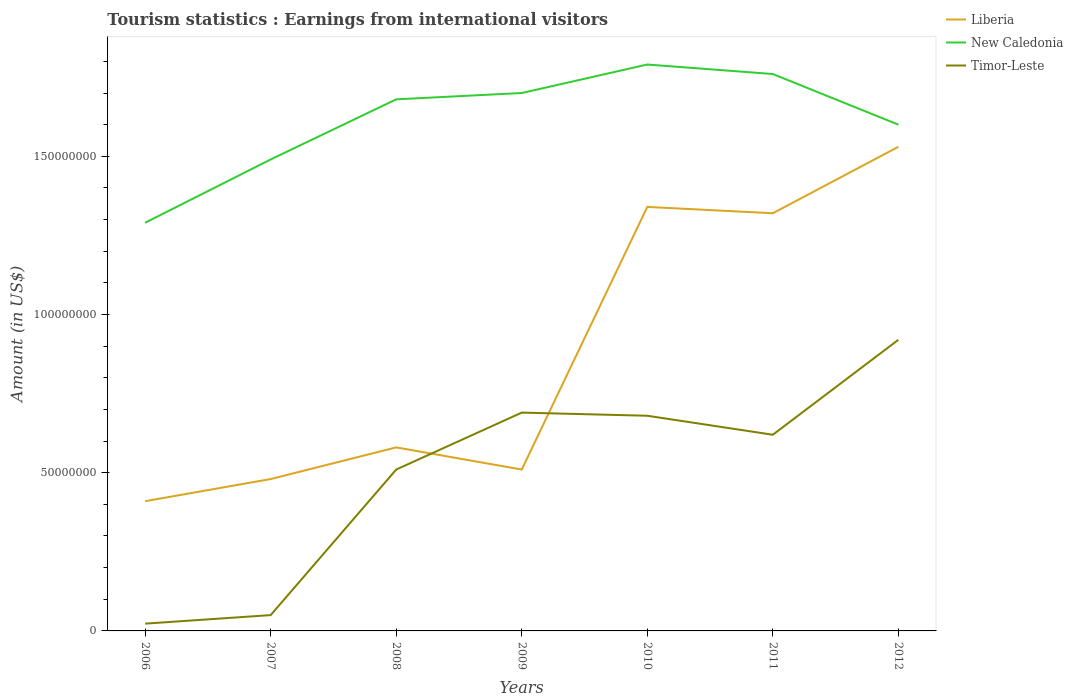How many different coloured lines are there?
Keep it short and to the point. 3. Does the line corresponding to Timor-Leste intersect with the line corresponding to Liberia?
Keep it short and to the point. Yes. Is the number of lines equal to the number of legend labels?
Offer a terse response. Yes. Across all years, what is the maximum earnings from international visitors in Liberia?
Offer a terse response. 4.10e+07. What is the total earnings from international visitors in Timor-Leste in the graph?
Your answer should be very brief. -1.80e+07. What is the difference between the highest and the second highest earnings from international visitors in Timor-Leste?
Make the answer very short. 8.97e+07. Is the earnings from international visitors in Liberia strictly greater than the earnings from international visitors in Timor-Leste over the years?
Provide a succinct answer. No. How many lines are there?
Provide a short and direct response. 3. How many years are there in the graph?
Provide a succinct answer. 7. Does the graph contain any zero values?
Provide a succinct answer. No. Does the graph contain grids?
Keep it short and to the point. No. Where does the legend appear in the graph?
Your response must be concise. Top right. How are the legend labels stacked?
Offer a very short reply. Vertical. What is the title of the graph?
Your answer should be very brief. Tourism statistics : Earnings from international visitors. What is the Amount (in US$) of Liberia in 2006?
Make the answer very short. 4.10e+07. What is the Amount (in US$) in New Caledonia in 2006?
Give a very brief answer. 1.29e+08. What is the Amount (in US$) in Timor-Leste in 2006?
Provide a succinct answer. 2.30e+06. What is the Amount (in US$) of Liberia in 2007?
Your answer should be compact. 4.80e+07. What is the Amount (in US$) in New Caledonia in 2007?
Provide a succinct answer. 1.49e+08. What is the Amount (in US$) in Timor-Leste in 2007?
Offer a terse response. 5.00e+06. What is the Amount (in US$) in Liberia in 2008?
Keep it short and to the point. 5.80e+07. What is the Amount (in US$) in New Caledonia in 2008?
Provide a succinct answer. 1.68e+08. What is the Amount (in US$) of Timor-Leste in 2008?
Keep it short and to the point. 5.10e+07. What is the Amount (in US$) of Liberia in 2009?
Give a very brief answer. 5.10e+07. What is the Amount (in US$) in New Caledonia in 2009?
Provide a short and direct response. 1.70e+08. What is the Amount (in US$) of Timor-Leste in 2009?
Provide a succinct answer. 6.90e+07. What is the Amount (in US$) in Liberia in 2010?
Provide a short and direct response. 1.34e+08. What is the Amount (in US$) in New Caledonia in 2010?
Provide a succinct answer. 1.79e+08. What is the Amount (in US$) of Timor-Leste in 2010?
Provide a succinct answer. 6.80e+07. What is the Amount (in US$) in Liberia in 2011?
Your answer should be very brief. 1.32e+08. What is the Amount (in US$) of New Caledonia in 2011?
Keep it short and to the point. 1.76e+08. What is the Amount (in US$) in Timor-Leste in 2011?
Keep it short and to the point. 6.20e+07. What is the Amount (in US$) of Liberia in 2012?
Ensure brevity in your answer.  1.53e+08. What is the Amount (in US$) in New Caledonia in 2012?
Your answer should be compact. 1.60e+08. What is the Amount (in US$) of Timor-Leste in 2012?
Your answer should be very brief. 9.20e+07. Across all years, what is the maximum Amount (in US$) of Liberia?
Provide a short and direct response. 1.53e+08. Across all years, what is the maximum Amount (in US$) in New Caledonia?
Provide a short and direct response. 1.79e+08. Across all years, what is the maximum Amount (in US$) of Timor-Leste?
Your response must be concise. 9.20e+07. Across all years, what is the minimum Amount (in US$) in Liberia?
Your answer should be compact. 4.10e+07. Across all years, what is the minimum Amount (in US$) in New Caledonia?
Make the answer very short. 1.29e+08. Across all years, what is the minimum Amount (in US$) in Timor-Leste?
Give a very brief answer. 2.30e+06. What is the total Amount (in US$) in Liberia in the graph?
Provide a succinct answer. 6.17e+08. What is the total Amount (in US$) in New Caledonia in the graph?
Your answer should be very brief. 1.13e+09. What is the total Amount (in US$) of Timor-Leste in the graph?
Give a very brief answer. 3.49e+08. What is the difference between the Amount (in US$) in Liberia in 2006 and that in 2007?
Keep it short and to the point. -7.00e+06. What is the difference between the Amount (in US$) of New Caledonia in 2006 and that in 2007?
Your answer should be compact. -2.00e+07. What is the difference between the Amount (in US$) of Timor-Leste in 2006 and that in 2007?
Offer a terse response. -2.70e+06. What is the difference between the Amount (in US$) in Liberia in 2006 and that in 2008?
Your answer should be very brief. -1.70e+07. What is the difference between the Amount (in US$) of New Caledonia in 2006 and that in 2008?
Offer a very short reply. -3.90e+07. What is the difference between the Amount (in US$) in Timor-Leste in 2006 and that in 2008?
Your answer should be very brief. -4.87e+07. What is the difference between the Amount (in US$) in Liberia in 2006 and that in 2009?
Provide a succinct answer. -1.00e+07. What is the difference between the Amount (in US$) of New Caledonia in 2006 and that in 2009?
Make the answer very short. -4.10e+07. What is the difference between the Amount (in US$) of Timor-Leste in 2006 and that in 2009?
Give a very brief answer. -6.67e+07. What is the difference between the Amount (in US$) in Liberia in 2006 and that in 2010?
Your answer should be very brief. -9.30e+07. What is the difference between the Amount (in US$) of New Caledonia in 2006 and that in 2010?
Offer a terse response. -5.00e+07. What is the difference between the Amount (in US$) in Timor-Leste in 2006 and that in 2010?
Your response must be concise. -6.57e+07. What is the difference between the Amount (in US$) in Liberia in 2006 and that in 2011?
Keep it short and to the point. -9.10e+07. What is the difference between the Amount (in US$) in New Caledonia in 2006 and that in 2011?
Offer a very short reply. -4.70e+07. What is the difference between the Amount (in US$) in Timor-Leste in 2006 and that in 2011?
Offer a terse response. -5.97e+07. What is the difference between the Amount (in US$) in Liberia in 2006 and that in 2012?
Your answer should be compact. -1.12e+08. What is the difference between the Amount (in US$) of New Caledonia in 2006 and that in 2012?
Your answer should be very brief. -3.10e+07. What is the difference between the Amount (in US$) in Timor-Leste in 2006 and that in 2012?
Offer a very short reply. -8.97e+07. What is the difference between the Amount (in US$) of Liberia in 2007 and that in 2008?
Your answer should be compact. -1.00e+07. What is the difference between the Amount (in US$) in New Caledonia in 2007 and that in 2008?
Keep it short and to the point. -1.90e+07. What is the difference between the Amount (in US$) of Timor-Leste in 2007 and that in 2008?
Offer a terse response. -4.60e+07. What is the difference between the Amount (in US$) in Liberia in 2007 and that in 2009?
Make the answer very short. -3.00e+06. What is the difference between the Amount (in US$) in New Caledonia in 2007 and that in 2009?
Make the answer very short. -2.10e+07. What is the difference between the Amount (in US$) of Timor-Leste in 2007 and that in 2009?
Give a very brief answer. -6.40e+07. What is the difference between the Amount (in US$) in Liberia in 2007 and that in 2010?
Your response must be concise. -8.60e+07. What is the difference between the Amount (in US$) of New Caledonia in 2007 and that in 2010?
Give a very brief answer. -3.00e+07. What is the difference between the Amount (in US$) in Timor-Leste in 2007 and that in 2010?
Provide a succinct answer. -6.30e+07. What is the difference between the Amount (in US$) of Liberia in 2007 and that in 2011?
Keep it short and to the point. -8.40e+07. What is the difference between the Amount (in US$) in New Caledonia in 2007 and that in 2011?
Keep it short and to the point. -2.70e+07. What is the difference between the Amount (in US$) of Timor-Leste in 2007 and that in 2011?
Make the answer very short. -5.70e+07. What is the difference between the Amount (in US$) in Liberia in 2007 and that in 2012?
Ensure brevity in your answer.  -1.05e+08. What is the difference between the Amount (in US$) of New Caledonia in 2007 and that in 2012?
Give a very brief answer. -1.10e+07. What is the difference between the Amount (in US$) of Timor-Leste in 2007 and that in 2012?
Provide a short and direct response. -8.70e+07. What is the difference between the Amount (in US$) in Timor-Leste in 2008 and that in 2009?
Offer a terse response. -1.80e+07. What is the difference between the Amount (in US$) in Liberia in 2008 and that in 2010?
Offer a very short reply. -7.60e+07. What is the difference between the Amount (in US$) in New Caledonia in 2008 and that in 2010?
Your answer should be compact. -1.10e+07. What is the difference between the Amount (in US$) of Timor-Leste in 2008 and that in 2010?
Keep it short and to the point. -1.70e+07. What is the difference between the Amount (in US$) of Liberia in 2008 and that in 2011?
Provide a short and direct response. -7.40e+07. What is the difference between the Amount (in US$) in New Caledonia in 2008 and that in 2011?
Make the answer very short. -8.00e+06. What is the difference between the Amount (in US$) of Timor-Leste in 2008 and that in 2011?
Your answer should be very brief. -1.10e+07. What is the difference between the Amount (in US$) of Liberia in 2008 and that in 2012?
Keep it short and to the point. -9.50e+07. What is the difference between the Amount (in US$) of Timor-Leste in 2008 and that in 2012?
Your response must be concise. -4.10e+07. What is the difference between the Amount (in US$) in Liberia in 2009 and that in 2010?
Keep it short and to the point. -8.30e+07. What is the difference between the Amount (in US$) of New Caledonia in 2009 and that in 2010?
Your answer should be compact. -9.00e+06. What is the difference between the Amount (in US$) in Timor-Leste in 2009 and that in 2010?
Offer a very short reply. 1.00e+06. What is the difference between the Amount (in US$) of Liberia in 2009 and that in 2011?
Provide a short and direct response. -8.10e+07. What is the difference between the Amount (in US$) in New Caledonia in 2009 and that in 2011?
Provide a succinct answer. -6.00e+06. What is the difference between the Amount (in US$) of Liberia in 2009 and that in 2012?
Give a very brief answer. -1.02e+08. What is the difference between the Amount (in US$) in Timor-Leste in 2009 and that in 2012?
Your answer should be compact. -2.30e+07. What is the difference between the Amount (in US$) in Liberia in 2010 and that in 2011?
Your answer should be very brief. 2.00e+06. What is the difference between the Amount (in US$) of Timor-Leste in 2010 and that in 2011?
Your response must be concise. 6.00e+06. What is the difference between the Amount (in US$) in Liberia in 2010 and that in 2012?
Make the answer very short. -1.90e+07. What is the difference between the Amount (in US$) of New Caledonia in 2010 and that in 2012?
Provide a succinct answer. 1.90e+07. What is the difference between the Amount (in US$) in Timor-Leste in 2010 and that in 2012?
Give a very brief answer. -2.40e+07. What is the difference between the Amount (in US$) in Liberia in 2011 and that in 2012?
Provide a short and direct response. -2.10e+07. What is the difference between the Amount (in US$) of New Caledonia in 2011 and that in 2012?
Your answer should be compact. 1.60e+07. What is the difference between the Amount (in US$) of Timor-Leste in 2011 and that in 2012?
Offer a terse response. -3.00e+07. What is the difference between the Amount (in US$) in Liberia in 2006 and the Amount (in US$) in New Caledonia in 2007?
Offer a terse response. -1.08e+08. What is the difference between the Amount (in US$) of Liberia in 2006 and the Amount (in US$) of Timor-Leste in 2007?
Provide a short and direct response. 3.60e+07. What is the difference between the Amount (in US$) of New Caledonia in 2006 and the Amount (in US$) of Timor-Leste in 2007?
Offer a terse response. 1.24e+08. What is the difference between the Amount (in US$) of Liberia in 2006 and the Amount (in US$) of New Caledonia in 2008?
Provide a succinct answer. -1.27e+08. What is the difference between the Amount (in US$) of Liberia in 2006 and the Amount (in US$) of Timor-Leste in 2008?
Your response must be concise. -1.00e+07. What is the difference between the Amount (in US$) of New Caledonia in 2006 and the Amount (in US$) of Timor-Leste in 2008?
Offer a very short reply. 7.80e+07. What is the difference between the Amount (in US$) of Liberia in 2006 and the Amount (in US$) of New Caledonia in 2009?
Offer a terse response. -1.29e+08. What is the difference between the Amount (in US$) in Liberia in 2006 and the Amount (in US$) in Timor-Leste in 2009?
Offer a very short reply. -2.80e+07. What is the difference between the Amount (in US$) in New Caledonia in 2006 and the Amount (in US$) in Timor-Leste in 2009?
Your answer should be compact. 6.00e+07. What is the difference between the Amount (in US$) of Liberia in 2006 and the Amount (in US$) of New Caledonia in 2010?
Make the answer very short. -1.38e+08. What is the difference between the Amount (in US$) of Liberia in 2006 and the Amount (in US$) of Timor-Leste in 2010?
Provide a succinct answer. -2.70e+07. What is the difference between the Amount (in US$) of New Caledonia in 2006 and the Amount (in US$) of Timor-Leste in 2010?
Your answer should be very brief. 6.10e+07. What is the difference between the Amount (in US$) in Liberia in 2006 and the Amount (in US$) in New Caledonia in 2011?
Keep it short and to the point. -1.35e+08. What is the difference between the Amount (in US$) of Liberia in 2006 and the Amount (in US$) of Timor-Leste in 2011?
Keep it short and to the point. -2.10e+07. What is the difference between the Amount (in US$) in New Caledonia in 2006 and the Amount (in US$) in Timor-Leste in 2011?
Provide a succinct answer. 6.70e+07. What is the difference between the Amount (in US$) in Liberia in 2006 and the Amount (in US$) in New Caledonia in 2012?
Your answer should be very brief. -1.19e+08. What is the difference between the Amount (in US$) of Liberia in 2006 and the Amount (in US$) of Timor-Leste in 2012?
Your answer should be compact. -5.10e+07. What is the difference between the Amount (in US$) in New Caledonia in 2006 and the Amount (in US$) in Timor-Leste in 2012?
Provide a succinct answer. 3.70e+07. What is the difference between the Amount (in US$) of Liberia in 2007 and the Amount (in US$) of New Caledonia in 2008?
Offer a very short reply. -1.20e+08. What is the difference between the Amount (in US$) in New Caledonia in 2007 and the Amount (in US$) in Timor-Leste in 2008?
Keep it short and to the point. 9.80e+07. What is the difference between the Amount (in US$) of Liberia in 2007 and the Amount (in US$) of New Caledonia in 2009?
Make the answer very short. -1.22e+08. What is the difference between the Amount (in US$) in Liberia in 2007 and the Amount (in US$) in Timor-Leste in 2009?
Provide a succinct answer. -2.10e+07. What is the difference between the Amount (in US$) of New Caledonia in 2007 and the Amount (in US$) of Timor-Leste in 2009?
Make the answer very short. 8.00e+07. What is the difference between the Amount (in US$) of Liberia in 2007 and the Amount (in US$) of New Caledonia in 2010?
Your answer should be compact. -1.31e+08. What is the difference between the Amount (in US$) in Liberia in 2007 and the Amount (in US$) in Timor-Leste in 2010?
Provide a short and direct response. -2.00e+07. What is the difference between the Amount (in US$) in New Caledonia in 2007 and the Amount (in US$) in Timor-Leste in 2010?
Keep it short and to the point. 8.10e+07. What is the difference between the Amount (in US$) in Liberia in 2007 and the Amount (in US$) in New Caledonia in 2011?
Your answer should be very brief. -1.28e+08. What is the difference between the Amount (in US$) in Liberia in 2007 and the Amount (in US$) in Timor-Leste in 2011?
Your response must be concise. -1.40e+07. What is the difference between the Amount (in US$) in New Caledonia in 2007 and the Amount (in US$) in Timor-Leste in 2011?
Your answer should be very brief. 8.70e+07. What is the difference between the Amount (in US$) in Liberia in 2007 and the Amount (in US$) in New Caledonia in 2012?
Ensure brevity in your answer.  -1.12e+08. What is the difference between the Amount (in US$) in Liberia in 2007 and the Amount (in US$) in Timor-Leste in 2012?
Your response must be concise. -4.40e+07. What is the difference between the Amount (in US$) of New Caledonia in 2007 and the Amount (in US$) of Timor-Leste in 2012?
Keep it short and to the point. 5.70e+07. What is the difference between the Amount (in US$) in Liberia in 2008 and the Amount (in US$) in New Caledonia in 2009?
Provide a succinct answer. -1.12e+08. What is the difference between the Amount (in US$) of Liberia in 2008 and the Amount (in US$) of Timor-Leste in 2009?
Your answer should be very brief. -1.10e+07. What is the difference between the Amount (in US$) of New Caledonia in 2008 and the Amount (in US$) of Timor-Leste in 2009?
Your answer should be very brief. 9.90e+07. What is the difference between the Amount (in US$) of Liberia in 2008 and the Amount (in US$) of New Caledonia in 2010?
Provide a short and direct response. -1.21e+08. What is the difference between the Amount (in US$) in Liberia in 2008 and the Amount (in US$) in Timor-Leste in 2010?
Give a very brief answer. -1.00e+07. What is the difference between the Amount (in US$) in Liberia in 2008 and the Amount (in US$) in New Caledonia in 2011?
Offer a very short reply. -1.18e+08. What is the difference between the Amount (in US$) in New Caledonia in 2008 and the Amount (in US$) in Timor-Leste in 2011?
Give a very brief answer. 1.06e+08. What is the difference between the Amount (in US$) of Liberia in 2008 and the Amount (in US$) of New Caledonia in 2012?
Your answer should be compact. -1.02e+08. What is the difference between the Amount (in US$) of Liberia in 2008 and the Amount (in US$) of Timor-Leste in 2012?
Ensure brevity in your answer.  -3.40e+07. What is the difference between the Amount (in US$) in New Caledonia in 2008 and the Amount (in US$) in Timor-Leste in 2012?
Provide a short and direct response. 7.60e+07. What is the difference between the Amount (in US$) of Liberia in 2009 and the Amount (in US$) of New Caledonia in 2010?
Make the answer very short. -1.28e+08. What is the difference between the Amount (in US$) of Liberia in 2009 and the Amount (in US$) of Timor-Leste in 2010?
Keep it short and to the point. -1.70e+07. What is the difference between the Amount (in US$) of New Caledonia in 2009 and the Amount (in US$) of Timor-Leste in 2010?
Your answer should be very brief. 1.02e+08. What is the difference between the Amount (in US$) of Liberia in 2009 and the Amount (in US$) of New Caledonia in 2011?
Offer a terse response. -1.25e+08. What is the difference between the Amount (in US$) of Liberia in 2009 and the Amount (in US$) of Timor-Leste in 2011?
Your answer should be very brief. -1.10e+07. What is the difference between the Amount (in US$) of New Caledonia in 2009 and the Amount (in US$) of Timor-Leste in 2011?
Keep it short and to the point. 1.08e+08. What is the difference between the Amount (in US$) of Liberia in 2009 and the Amount (in US$) of New Caledonia in 2012?
Your answer should be compact. -1.09e+08. What is the difference between the Amount (in US$) in Liberia in 2009 and the Amount (in US$) in Timor-Leste in 2012?
Your answer should be compact. -4.10e+07. What is the difference between the Amount (in US$) of New Caledonia in 2009 and the Amount (in US$) of Timor-Leste in 2012?
Make the answer very short. 7.80e+07. What is the difference between the Amount (in US$) in Liberia in 2010 and the Amount (in US$) in New Caledonia in 2011?
Your answer should be very brief. -4.20e+07. What is the difference between the Amount (in US$) in Liberia in 2010 and the Amount (in US$) in Timor-Leste in 2011?
Your response must be concise. 7.20e+07. What is the difference between the Amount (in US$) of New Caledonia in 2010 and the Amount (in US$) of Timor-Leste in 2011?
Your response must be concise. 1.17e+08. What is the difference between the Amount (in US$) of Liberia in 2010 and the Amount (in US$) of New Caledonia in 2012?
Offer a very short reply. -2.60e+07. What is the difference between the Amount (in US$) of Liberia in 2010 and the Amount (in US$) of Timor-Leste in 2012?
Make the answer very short. 4.20e+07. What is the difference between the Amount (in US$) in New Caledonia in 2010 and the Amount (in US$) in Timor-Leste in 2012?
Your response must be concise. 8.70e+07. What is the difference between the Amount (in US$) of Liberia in 2011 and the Amount (in US$) of New Caledonia in 2012?
Ensure brevity in your answer.  -2.80e+07. What is the difference between the Amount (in US$) in Liberia in 2011 and the Amount (in US$) in Timor-Leste in 2012?
Your answer should be compact. 4.00e+07. What is the difference between the Amount (in US$) in New Caledonia in 2011 and the Amount (in US$) in Timor-Leste in 2012?
Your answer should be compact. 8.40e+07. What is the average Amount (in US$) in Liberia per year?
Offer a terse response. 8.81e+07. What is the average Amount (in US$) of New Caledonia per year?
Your response must be concise. 1.62e+08. What is the average Amount (in US$) of Timor-Leste per year?
Ensure brevity in your answer.  4.99e+07. In the year 2006, what is the difference between the Amount (in US$) in Liberia and Amount (in US$) in New Caledonia?
Provide a short and direct response. -8.80e+07. In the year 2006, what is the difference between the Amount (in US$) in Liberia and Amount (in US$) in Timor-Leste?
Your response must be concise. 3.87e+07. In the year 2006, what is the difference between the Amount (in US$) of New Caledonia and Amount (in US$) of Timor-Leste?
Your response must be concise. 1.27e+08. In the year 2007, what is the difference between the Amount (in US$) in Liberia and Amount (in US$) in New Caledonia?
Ensure brevity in your answer.  -1.01e+08. In the year 2007, what is the difference between the Amount (in US$) in Liberia and Amount (in US$) in Timor-Leste?
Your answer should be compact. 4.30e+07. In the year 2007, what is the difference between the Amount (in US$) in New Caledonia and Amount (in US$) in Timor-Leste?
Give a very brief answer. 1.44e+08. In the year 2008, what is the difference between the Amount (in US$) of Liberia and Amount (in US$) of New Caledonia?
Ensure brevity in your answer.  -1.10e+08. In the year 2008, what is the difference between the Amount (in US$) in Liberia and Amount (in US$) in Timor-Leste?
Offer a terse response. 7.00e+06. In the year 2008, what is the difference between the Amount (in US$) in New Caledonia and Amount (in US$) in Timor-Leste?
Offer a terse response. 1.17e+08. In the year 2009, what is the difference between the Amount (in US$) in Liberia and Amount (in US$) in New Caledonia?
Your response must be concise. -1.19e+08. In the year 2009, what is the difference between the Amount (in US$) in Liberia and Amount (in US$) in Timor-Leste?
Make the answer very short. -1.80e+07. In the year 2009, what is the difference between the Amount (in US$) in New Caledonia and Amount (in US$) in Timor-Leste?
Offer a very short reply. 1.01e+08. In the year 2010, what is the difference between the Amount (in US$) in Liberia and Amount (in US$) in New Caledonia?
Your answer should be very brief. -4.50e+07. In the year 2010, what is the difference between the Amount (in US$) of Liberia and Amount (in US$) of Timor-Leste?
Give a very brief answer. 6.60e+07. In the year 2010, what is the difference between the Amount (in US$) in New Caledonia and Amount (in US$) in Timor-Leste?
Offer a very short reply. 1.11e+08. In the year 2011, what is the difference between the Amount (in US$) of Liberia and Amount (in US$) of New Caledonia?
Provide a succinct answer. -4.40e+07. In the year 2011, what is the difference between the Amount (in US$) of Liberia and Amount (in US$) of Timor-Leste?
Provide a succinct answer. 7.00e+07. In the year 2011, what is the difference between the Amount (in US$) of New Caledonia and Amount (in US$) of Timor-Leste?
Your response must be concise. 1.14e+08. In the year 2012, what is the difference between the Amount (in US$) of Liberia and Amount (in US$) of New Caledonia?
Your answer should be very brief. -7.00e+06. In the year 2012, what is the difference between the Amount (in US$) in Liberia and Amount (in US$) in Timor-Leste?
Ensure brevity in your answer.  6.10e+07. In the year 2012, what is the difference between the Amount (in US$) of New Caledonia and Amount (in US$) of Timor-Leste?
Provide a short and direct response. 6.80e+07. What is the ratio of the Amount (in US$) of Liberia in 2006 to that in 2007?
Your answer should be very brief. 0.85. What is the ratio of the Amount (in US$) in New Caledonia in 2006 to that in 2007?
Keep it short and to the point. 0.87. What is the ratio of the Amount (in US$) in Timor-Leste in 2006 to that in 2007?
Ensure brevity in your answer.  0.46. What is the ratio of the Amount (in US$) in Liberia in 2006 to that in 2008?
Provide a succinct answer. 0.71. What is the ratio of the Amount (in US$) in New Caledonia in 2006 to that in 2008?
Offer a terse response. 0.77. What is the ratio of the Amount (in US$) of Timor-Leste in 2006 to that in 2008?
Provide a short and direct response. 0.05. What is the ratio of the Amount (in US$) in Liberia in 2006 to that in 2009?
Give a very brief answer. 0.8. What is the ratio of the Amount (in US$) of New Caledonia in 2006 to that in 2009?
Ensure brevity in your answer.  0.76. What is the ratio of the Amount (in US$) of Timor-Leste in 2006 to that in 2009?
Your response must be concise. 0.03. What is the ratio of the Amount (in US$) of Liberia in 2006 to that in 2010?
Your answer should be compact. 0.31. What is the ratio of the Amount (in US$) of New Caledonia in 2006 to that in 2010?
Your answer should be very brief. 0.72. What is the ratio of the Amount (in US$) of Timor-Leste in 2006 to that in 2010?
Provide a succinct answer. 0.03. What is the ratio of the Amount (in US$) of Liberia in 2006 to that in 2011?
Make the answer very short. 0.31. What is the ratio of the Amount (in US$) in New Caledonia in 2006 to that in 2011?
Give a very brief answer. 0.73. What is the ratio of the Amount (in US$) of Timor-Leste in 2006 to that in 2011?
Ensure brevity in your answer.  0.04. What is the ratio of the Amount (in US$) in Liberia in 2006 to that in 2012?
Offer a terse response. 0.27. What is the ratio of the Amount (in US$) of New Caledonia in 2006 to that in 2012?
Provide a short and direct response. 0.81. What is the ratio of the Amount (in US$) of Timor-Leste in 2006 to that in 2012?
Provide a short and direct response. 0.03. What is the ratio of the Amount (in US$) in Liberia in 2007 to that in 2008?
Keep it short and to the point. 0.83. What is the ratio of the Amount (in US$) in New Caledonia in 2007 to that in 2008?
Keep it short and to the point. 0.89. What is the ratio of the Amount (in US$) in Timor-Leste in 2007 to that in 2008?
Provide a short and direct response. 0.1. What is the ratio of the Amount (in US$) in Liberia in 2007 to that in 2009?
Make the answer very short. 0.94. What is the ratio of the Amount (in US$) of New Caledonia in 2007 to that in 2009?
Offer a very short reply. 0.88. What is the ratio of the Amount (in US$) in Timor-Leste in 2007 to that in 2009?
Your answer should be very brief. 0.07. What is the ratio of the Amount (in US$) in Liberia in 2007 to that in 2010?
Provide a short and direct response. 0.36. What is the ratio of the Amount (in US$) of New Caledonia in 2007 to that in 2010?
Give a very brief answer. 0.83. What is the ratio of the Amount (in US$) of Timor-Leste in 2007 to that in 2010?
Your answer should be very brief. 0.07. What is the ratio of the Amount (in US$) of Liberia in 2007 to that in 2011?
Give a very brief answer. 0.36. What is the ratio of the Amount (in US$) of New Caledonia in 2007 to that in 2011?
Offer a terse response. 0.85. What is the ratio of the Amount (in US$) of Timor-Leste in 2007 to that in 2011?
Provide a short and direct response. 0.08. What is the ratio of the Amount (in US$) of Liberia in 2007 to that in 2012?
Your response must be concise. 0.31. What is the ratio of the Amount (in US$) of New Caledonia in 2007 to that in 2012?
Your answer should be very brief. 0.93. What is the ratio of the Amount (in US$) in Timor-Leste in 2007 to that in 2012?
Ensure brevity in your answer.  0.05. What is the ratio of the Amount (in US$) of Liberia in 2008 to that in 2009?
Provide a short and direct response. 1.14. What is the ratio of the Amount (in US$) of New Caledonia in 2008 to that in 2009?
Make the answer very short. 0.99. What is the ratio of the Amount (in US$) of Timor-Leste in 2008 to that in 2009?
Your answer should be compact. 0.74. What is the ratio of the Amount (in US$) of Liberia in 2008 to that in 2010?
Ensure brevity in your answer.  0.43. What is the ratio of the Amount (in US$) of New Caledonia in 2008 to that in 2010?
Offer a very short reply. 0.94. What is the ratio of the Amount (in US$) in Timor-Leste in 2008 to that in 2010?
Keep it short and to the point. 0.75. What is the ratio of the Amount (in US$) of Liberia in 2008 to that in 2011?
Your answer should be compact. 0.44. What is the ratio of the Amount (in US$) in New Caledonia in 2008 to that in 2011?
Keep it short and to the point. 0.95. What is the ratio of the Amount (in US$) of Timor-Leste in 2008 to that in 2011?
Provide a short and direct response. 0.82. What is the ratio of the Amount (in US$) of Liberia in 2008 to that in 2012?
Provide a short and direct response. 0.38. What is the ratio of the Amount (in US$) of Timor-Leste in 2008 to that in 2012?
Your answer should be very brief. 0.55. What is the ratio of the Amount (in US$) in Liberia in 2009 to that in 2010?
Give a very brief answer. 0.38. What is the ratio of the Amount (in US$) of New Caledonia in 2009 to that in 2010?
Provide a succinct answer. 0.95. What is the ratio of the Amount (in US$) of Timor-Leste in 2009 to that in 2010?
Ensure brevity in your answer.  1.01. What is the ratio of the Amount (in US$) of Liberia in 2009 to that in 2011?
Give a very brief answer. 0.39. What is the ratio of the Amount (in US$) of New Caledonia in 2009 to that in 2011?
Offer a very short reply. 0.97. What is the ratio of the Amount (in US$) in Timor-Leste in 2009 to that in 2011?
Offer a very short reply. 1.11. What is the ratio of the Amount (in US$) of Liberia in 2009 to that in 2012?
Your answer should be very brief. 0.33. What is the ratio of the Amount (in US$) of Liberia in 2010 to that in 2011?
Keep it short and to the point. 1.02. What is the ratio of the Amount (in US$) of Timor-Leste in 2010 to that in 2011?
Your answer should be compact. 1.1. What is the ratio of the Amount (in US$) in Liberia in 2010 to that in 2012?
Offer a very short reply. 0.88. What is the ratio of the Amount (in US$) in New Caledonia in 2010 to that in 2012?
Keep it short and to the point. 1.12. What is the ratio of the Amount (in US$) in Timor-Leste in 2010 to that in 2012?
Provide a succinct answer. 0.74. What is the ratio of the Amount (in US$) of Liberia in 2011 to that in 2012?
Provide a succinct answer. 0.86. What is the ratio of the Amount (in US$) of New Caledonia in 2011 to that in 2012?
Offer a terse response. 1.1. What is the ratio of the Amount (in US$) of Timor-Leste in 2011 to that in 2012?
Provide a succinct answer. 0.67. What is the difference between the highest and the second highest Amount (in US$) of Liberia?
Provide a succinct answer. 1.90e+07. What is the difference between the highest and the second highest Amount (in US$) in Timor-Leste?
Ensure brevity in your answer.  2.30e+07. What is the difference between the highest and the lowest Amount (in US$) of Liberia?
Give a very brief answer. 1.12e+08. What is the difference between the highest and the lowest Amount (in US$) in New Caledonia?
Provide a short and direct response. 5.00e+07. What is the difference between the highest and the lowest Amount (in US$) of Timor-Leste?
Make the answer very short. 8.97e+07. 